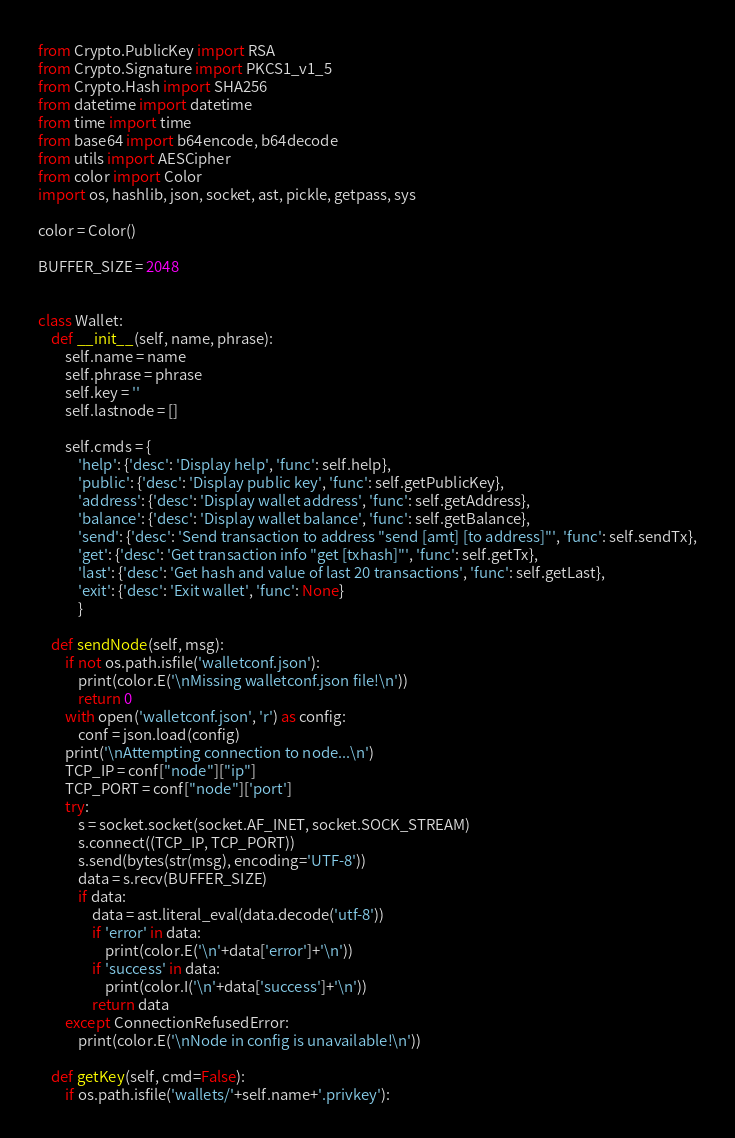<code> <loc_0><loc_0><loc_500><loc_500><_Python_>from Crypto.PublicKey import RSA
from Crypto.Signature import PKCS1_v1_5
from Crypto.Hash import SHA256
from datetime import datetime
from time import time
from base64 import b64encode, b64decode
from utils import AESCipher
from color import Color
import os, hashlib, json, socket, ast, pickle, getpass, sys

color = Color()

BUFFER_SIZE = 2048


class Wallet:
    def __init__(self, name, phrase):
        self.name = name
        self.phrase = phrase
        self.key = ''
        self.lastnode = []

        self.cmds = {
            'help': {'desc': 'Display help', 'func': self.help},
            'public': {'desc': 'Display public key', 'func': self.getPublicKey},
            'address': {'desc': 'Display wallet address', 'func': self.getAddress},
            'balance': {'desc': 'Display wallet balance', 'func': self.getBalance},
            'send': {'desc': 'Send transaction to address "send [amt] [to address]"', 'func': self.sendTx},
            'get': {'desc': 'Get transaction info "get [txhash]"', 'func': self.getTx},
            'last': {'desc': 'Get hash and value of last 20 transactions', 'func': self.getLast},
            'exit': {'desc': 'Exit wallet', 'func': None}
            }

    def sendNode(self, msg):
        if not os.path.isfile('walletconf.json'):
            print(color.E('\nMissing walletconf.json file!\n'))
            return 0
        with open('walletconf.json', 'r') as config:
            conf = json.load(config)
        print('\nAttempting connection to node...\n')
        TCP_IP = conf["node"]["ip"]
        TCP_PORT = conf["node"]['port']
        try:
            s = socket.socket(socket.AF_INET, socket.SOCK_STREAM)
            s.connect((TCP_IP, TCP_PORT))
            s.send(bytes(str(msg), encoding='UTF-8'))
            data = s.recv(BUFFER_SIZE)
            if data:
                data = ast.literal_eval(data.decode('utf-8'))
                if 'error' in data:
                    print(color.E('\n'+data['error']+'\n'))
                if 'success' in data:
                    print(color.I('\n'+data['success']+'\n'))
                return data
        except ConnectionRefusedError:
            print(color.E('\nNode in config is unavailable!\n'))

    def getKey(self, cmd=False):
        if os.path.isfile('wallets/'+self.name+'.privkey'):</code> 